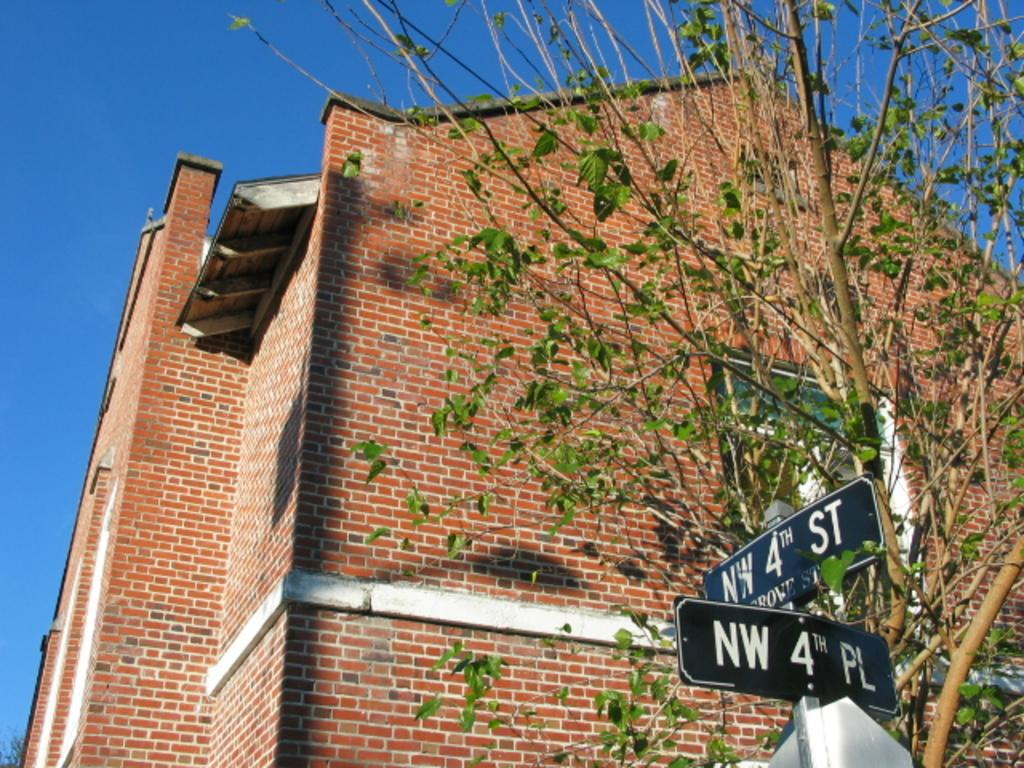<image>
Create a compact narrative representing the image presented. A street sign outside a house reads NW 4th St and NW 4th PL 